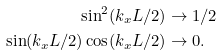<formula> <loc_0><loc_0><loc_500><loc_500>\sin ^ { 2 } ( k _ { x } L / 2 ) & \to 1 / 2 \\ \sin ( k _ { x } L / 2 ) \cos ( k _ { x } L / 2 ) & \to 0 .</formula> 